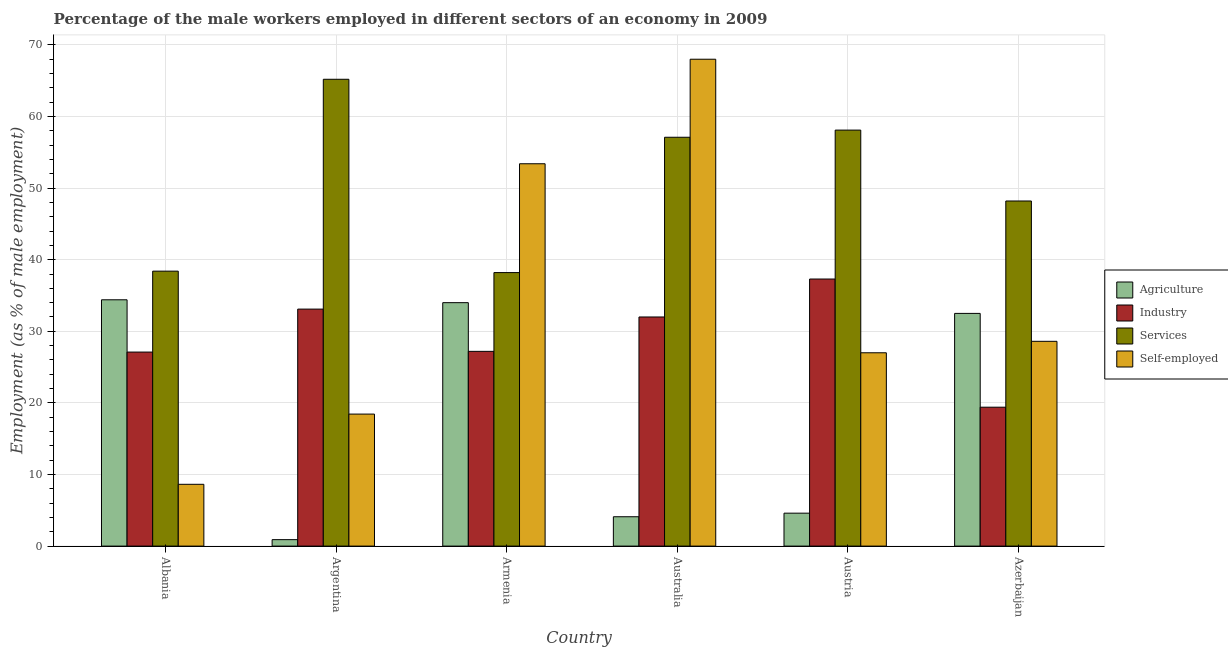How many groups of bars are there?
Make the answer very short. 6. Are the number of bars per tick equal to the number of legend labels?
Your response must be concise. Yes. Are the number of bars on each tick of the X-axis equal?
Keep it short and to the point. Yes. How many bars are there on the 1st tick from the right?
Keep it short and to the point. 4. What is the label of the 2nd group of bars from the left?
Your response must be concise. Argentina. What is the percentage of male workers in agriculture in Austria?
Give a very brief answer. 4.6. Across all countries, what is the maximum percentage of male workers in agriculture?
Your response must be concise. 34.4. Across all countries, what is the minimum percentage of male workers in industry?
Provide a short and direct response. 19.4. In which country was the percentage of male workers in services maximum?
Offer a very short reply. Argentina. In which country was the percentage of male workers in agriculture minimum?
Give a very brief answer. Argentina. What is the total percentage of male workers in services in the graph?
Your answer should be very brief. 305.2. What is the difference between the percentage of self employed male workers in Albania and that in Azerbaijan?
Your response must be concise. -19.97. What is the difference between the percentage of male workers in agriculture in Australia and the percentage of male workers in services in Azerbaijan?
Your answer should be very brief. -44.1. What is the average percentage of male workers in agriculture per country?
Make the answer very short. 18.42. What is the difference between the percentage of self employed male workers and percentage of male workers in industry in Albania?
Your answer should be very brief. -18.47. What is the ratio of the percentage of self employed male workers in Albania to that in Azerbaijan?
Offer a very short reply. 0.3. What is the difference between the highest and the second highest percentage of male workers in agriculture?
Your response must be concise. 0.4. What is the difference between the highest and the lowest percentage of male workers in agriculture?
Your answer should be compact. 33.5. In how many countries, is the percentage of male workers in industry greater than the average percentage of male workers in industry taken over all countries?
Offer a very short reply. 3. Is the sum of the percentage of male workers in services in Armenia and Azerbaijan greater than the maximum percentage of self employed male workers across all countries?
Make the answer very short. Yes. Is it the case that in every country, the sum of the percentage of male workers in services and percentage of male workers in agriculture is greater than the sum of percentage of male workers in industry and percentage of self employed male workers?
Provide a short and direct response. No. What does the 4th bar from the left in Armenia represents?
Your answer should be very brief. Self-employed. What does the 1st bar from the right in Austria represents?
Your response must be concise. Self-employed. Is it the case that in every country, the sum of the percentage of male workers in agriculture and percentage of male workers in industry is greater than the percentage of male workers in services?
Ensure brevity in your answer.  No. How many countries are there in the graph?
Your answer should be compact. 6. What is the difference between two consecutive major ticks on the Y-axis?
Provide a succinct answer. 10. Are the values on the major ticks of Y-axis written in scientific E-notation?
Make the answer very short. No. Where does the legend appear in the graph?
Offer a very short reply. Center right. What is the title of the graph?
Provide a succinct answer. Percentage of the male workers employed in different sectors of an economy in 2009. Does "Greece" appear as one of the legend labels in the graph?
Provide a short and direct response. No. What is the label or title of the X-axis?
Provide a short and direct response. Country. What is the label or title of the Y-axis?
Offer a very short reply. Employment (as % of male employment). What is the Employment (as % of male employment) of Agriculture in Albania?
Offer a very short reply. 34.4. What is the Employment (as % of male employment) of Industry in Albania?
Give a very brief answer. 27.1. What is the Employment (as % of male employment) of Services in Albania?
Give a very brief answer. 38.4. What is the Employment (as % of male employment) in Self-employed in Albania?
Offer a terse response. 8.63. What is the Employment (as % of male employment) of Agriculture in Argentina?
Provide a succinct answer. 0.9. What is the Employment (as % of male employment) of Industry in Argentina?
Provide a succinct answer. 33.1. What is the Employment (as % of male employment) of Services in Argentina?
Provide a short and direct response. 65.2. What is the Employment (as % of male employment) of Self-employed in Argentina?
Provide a short and direct response. 18.44. What is the Employment (as % of male employment) of Industry in Armenia?
Offer a very short reply. 27.2. What is the Employment (as % of male employment) in Services in Armenia?
Your response must be concise. 38.2. What is the Employment (as % of male employment) of Self-employed in Armenia?
Your answer should be compact. 53.4. What is the Employment (as % of male employment) of Agriculture in Australia?
Offer a terse response. 4.1. What is the Employment (as % of male employment) of Services in Australia?
Ensure brevity in your answer.  57.1. What is the Employment (as % of male employment) in Agriculture in Austria?
Ensure brevity in your answer.  4.6. What is the Employment (as % of male employment) in Industry in Austria?
Provide a succinct answer. 37.3. What is the Employment (as % of male employment) in Services in Austria?
Make the answer very short. 58.1. What is the Employment (as % of male employment) of Agriculture in Azerbaijan?
Your answer should be compact. 32.5. What is the Employment (as % of male employment) of Industry in Azerbaijan?
Give a very brief answer. 19.4. What is the Employment (as % of male employment) in Services in Azerbaijan?
Provide a succinct answer. 48.2. What is the Employment (as % of male employment) of Self-employed in Azerbaijan?
Give a very brief answer. 28.6. Across all countries, what is the maximum Employment (as % of male employment) of Agriculture?
Your answer should be very brief. 34.4. Across all countries, what is the maximum Employment (as % of male employment) of Industry?
Keep it short and to the point. 37.3. Across all countries, what is the maximum Employment (as % of male employment) in Services?
Ensure brevity in your answer.  65.2. Across all countries, what is the maximum Employment (as % of male employment) of Self-employed?
Give a very brief answer. 68. Across all countries, what is the minimum Employment (as % of male employment) in Agriculture?
Provide a short and direct response. 0.9. Across all countries, what is the minimum Employment (as % of male employment) of Industry?
Give a very brief answer. 19.4. Across all countries, what is the minimum Employment (as % of male employment) of Services?
Offer a terse response. 38.2. Across all countries, what is the minimum Employment (as % of male employment) in Self-employed?
Keep it short and to the point. 8.63. What is the total Employment (as % of male employment) of Agriculture in the graph?
Your answer should be very brief. 110.5. What is the total Employment (as % of male employment) of Industry in the graph?
Your answer should be compact. 176.1. What is the total Employment (as % of male employment) of Services in the graph?
Offer a very short reply. 305.2. What is the total Employment (as % of male employment) of Self-employed in the graph?
Keep it short and to the point. 204.07. What is the difference between the Employment (as % of male employment) of Agriculture in Albania and that in Argentina?
Your response must be concise. 33.5. What is the difference between the Employment (as % of male employment) in Services in Albania and that in Argentina?
Give a very brief answer. -26.8. What is the difference between the Employment (as % of male employment) in Self-employed in Albania and that in Argentina?
Your response must be concise. -9.81. What is the difference between the Employment (as % of male employment) of Agriculture in Albania and that in Armenia?
Make the answer very short. 0.4. What is the difference between the Employment (as % of male employment) of Industry in Albania and that in Armenia?
Offer a very short reply. -0.1. What is the difference between the Employment (as % of male employment) in Services in Albania and that in Armenia?
Your answer should be compact. 0.2. What is the difference between the Employment (as % of male employment) of Self-employed in Albania and that in Armenia?
Make the answer very short. -44.77. What is the difference between the Employment (as % of male employment) in Agriculture in Albania and that in Australia?
Offer a terse response. 30.3. What is the difference between the Employment (as % of male employment) in Services in Albania and that in Australia?
Keep it short and to the point. -18.7. What is the difference between the Employment (as % of male employment) in Self-employed in Albania and that in Australia?
Provide a succinct answer. -59.37. What is the difference between the Employment (as % of male employment) in Agriculture in Albania and that in Austria?
Offer a terse response. 29.8. What is the difference between the Employment (as % of male employment) in Industry in Albania and that in Austria?
Your response must be concise. -10.2. What is the difference between the Employment (as % of male employment) in Services in Albania and that in Austria?
Offer a terse response. -19.7. What is the difference between the Employment (as % of male employment) in Self-employed in Albania and that in Austria?
Offer a very short reply. -18.37. What is the difference between the Employment (as % of male employment) of Agriculture in Albania and that in Azerbaijan?
Your answer should be very brief. 1.9. What is the difference between the Employment (as % of male employment) of Industry in Albania and that in Azerbaijan?
Give a very brief answer. 7.7. What is the difference between the Employment (as % of male employment) of Services in Albania and that in Azerbaijan?
Keep it short and to the point. -9.8. What is the difference between the Employment (as % of male employment) in Self-employed in Albania and that in Azerbaijan?
Your response must be concise. -19.97. What is the difference between the Employment (as % of male employment) in Agriculture in Argentina and that in Armenia?
Your response must be concise. -33.1. What is the difference between the Employment (as % of male employment) in Industry in Argentina and that in Armenia?
Provide a short and direct response. 5.9. What is the difference between the Employment (as % of male employment) in Self-employed in Argentina and that in Armenia?
Your answer should be compact. -34.96. What is the difference between the Employment (as % of male employment) of Agriculture in Argentina and that in Australia?
Your response must be concise. -3.2. What is the difference between the Employment (as % of male employment) in Industry in Argentina and that in Australia?
Provide a succinct answer. 1.1. What is the difference between the Employment (as % of male employment) of Self-employed in Argentina and that in Australia?
Offer a terse response. -49.56. What is the difference between the Employment (as % of male employment) of Industry in Argentina and that in Austria?
Your answer should be very brief. -4.2. What is the difference between the Employment (as % of male employment) in Self-employed in Argentina and that in Austria?
Offer a very short reply. -8.56. What is the difference between the Employment (as % of male employment) in Agriculture in Argentina and that in Azerbaijan?
Give a very brief answer. -31.6. What is the difference between the Employment (as % of male employment) of Services in Argentina and that in Azerbaijan?
Your answer should be compact. 17. What is the difference between the Employment (as % of male employment) in Self-employed in Argentina and that in Azerbaijan?
Your answer should be very brief. -10.16. What is the difference between the Employment (as % of male employment) of Agriculture in Armenia and that in Australia?
Provide a short and direct response. 29.9. What is the difference between the Employment (as % of male employment) of Industry in Armenia and that in Australia?
Keep it short and to the point. -4.8. What is the difference between the Employment (as % of male employment) in Services in Armenia and that in Australia?
Keep it short and to the point. -18.9. What is the difference between the Employment (as % of male employment) in Self-employed in Armenia and that in Australia?
Keep it short and to the point. -14.6. What is the difference between the Employment (as % of male employment) of Agriculture in Armenia and that in Austria?
Provide a short and direct response. 29.4. What is the difference between the Employment (as % of male employment) of Services in Armenia and that in Austria?
Offer a terse response. -19.9. What is the difference between the Employment (as % of male employment) in Self-employed in Armenia and that in Austria?
Provide a succinct answer. 26.4. What is the difference between the Employment (as % of male employment) in Agriculture in Armenia and that in Azerbaijan?
Keep it short and to the point. 1.5. What is the difference between the Employment (as % of male employment) in Self-employed in Armenia and that in Azerbaijan?
Your answer should be compact. 24.8. What is the difference between the Employment (as % of male employment) of Agriculture in Australia and that in Austria?
Ensure brevity in your answer.  -0.5. What is the difference between the Employment (as % of male employment) of Self-employed in Australia and that in Austria?
Make the answer very short. 41. What is the difference between the Employment (as % of male employment) of Agriculture in Australia and that in Azerbaijan?
Ensure brevity in your answer.  -28.4. What is the difference between the Employment (as % of male employment) in Services in Australia and that in Azerbaijan?
Offer a terse response. 8.9. What is the difference between the Employment (as % of male employment) of Self-employed in Australia and that in Azerbaijan?
Provide a succinct answer. 39.4. What is the difference between the Employment (as % of male employment) in Agriculture in Austria and that in Azerbaijan?
Provide a succinct answer. -27.9. What is the difference between the Employment (as % of male employment) in Self-employed in Austria and that in Azerbaijan?
Offer a terse response. -1.6. What is the difference between the Employment (as % of male employment) of Agriculture in Albania and the Employment (as % of male employment) of Industry in Argentina?
Your answer should be compact. 1.3. What is the difference between the Employment (as % of male employment) of Agriculture in Albania and the Employment (as % of male employment) of Services in Argentina?
Give a very brief answer. -30.8. What is the difference between the Employment (as % of male employment) of Agriculture in Albania and the Employment (as % of male employment) of Self-employed in Argentina?
Give a very brief answer. 15.96. What is the difference between the Employment (as % of male employment) of Industry in Albania and the Employment (as % of male employment) of Services in Argentina?
Ensure brevity in your answer.  -38.1. What is the difference between the Employment (as % of male employment) in Industry in Albania and the Employment (as % of male employment) in Self-employed in Argentina?
Make the answer very short. 8.66. What is the difference between the Employment (as % of male employment) of Services in Albania and the Employment (as % of male employment) of Self-employed in Argentina?
Your response must be concise. 19.96. What is the difference between the Employment (as % of male employment) of Agriculture in Albania and the Employment (as % of male employment) of Self-employed in Armenia?
Keep it short and to the point. -19. What is the difference between the Employment (as % of male employment) of Industry in Albania and the Employment (as % of male employment) of Self-employed in Armenia?
Ensure brevity in your answer.  -26.3. What is the difference between the Employment (as % of male employment) of Agriculture in Albania and the Employment (as % of male employment) of Industry in Australia?
Provide a short and direct response. 2.4. What is the difference between the Employment (as % of male employment) in Agriculture in Albania and the Employment (as % of male employment) in Services in Australia?
Keep it short and to the point. -22.7. What is the difference between the Employment (as % of male employment) in Agriculture in Albania and the Employment (as % of male employment) in Self-employed in Australia?
Give a very brief answer. -33.6. What is the difference between the Employment (as % of male employment) of Industry in Albania and the Employment (as % of male employment) of Self-employed in Australia?
Offer a very short reply. -40.9. What is the difference between the Employment (as % of male employment) of Services in Albania and the Employment (as % of male employment) of Self-employed in Australia?
Offer a terse response. -29.6. What is the difference between the Employment (as % of male employment) in Agriculture in Albania and the Employment (as % of male employment) in Industry in Austria?
Your response must be concise. -2.9. What is the difference between the Employment (as % of male employment) in Agriculture in Albania and the Employment (as % of male employment) in Services in Austria?
Your answer should be very brief. -23.7. What is the difference between the Employment (as % of male employment) of Agriculture in Albania and the Employment (as % of male employment) of Self-employed in Austria?
Ensure brevity in your answer.  7.4. What is the difference between the Employment (as % of male employment) of Industry in Albania and the Employment (as % of male employment) of Services in Austria?
Offer a terse response. -31. What is the difference between the Employment (as % of male employment) in Services in Albania and the Employment (as % of male employment) in Self-employed in Austria?
Make the answer very short. 11.4. What is the difference between the Employment (as % of male employment) of Agriculture in Albania and the Employment (as % of male employment) of Services in Azerbaijan?
Provide a succinct answer. -13.8. What is the difference between the Employment (as % of male employment) in Agriculture in Albania and the Employment (as % of male employment) in Self-employed in Azerbaijan?
Make the answer very short. 5.8. What is the difference between the Employment (as % of male employment) of Industry in Albania and the Employment (as % of male employment) of Services in Azerbaijan?
Ensure brevity in your answer.  -21.1. What is the difference between the Employment (as % of male employment) of Industry in Albania and the Employment (as % of male employment) of Self-employed in Azerbaijan?
Ensure brevity in your answer.  -1.5. What is the difference between the Employment (as % of male employment) in Agriculture in Argentina and the Employment (as % of male employment) in Industry in Armenia?
Your answer should be compact. -26.3. What is the difference between the Employment (as % of male employment) of Agriculture in Argentina and the Employment (as % of male employment) of Services in Armenia?
Offer a terse response. -37.3. What is the difference between the Employment (as % of male employment) of Agriculture in Argentina and the Employment (as % of male employment) of Self-employed in Armenia?
Your answer should be very brief. -52.5. What is the difference between the Employment (as % of male employment) of Industry in Argentina and the Employment (as % of male employment) of Services in Armenia?
Make the answer very short. -5.1. What is the difference between the Employment (as % of male employment) in Industry in Argentina and the Employment (as % of male employment) in Self-employed in Armenia?
Provide a short and direct response. -20.3. What is the difference between the Employment (as % of male employment) in Services in Argentina and the Employment (as % of male employment) in Self-employed in Armenia?
Your answer should be compact. 11.8. What is the difference between the Employment (as % of male employment) in Agriculture in Argentina and the Employment (as % of male employment) in Industry in Australia?
Ensure brevity in your answer.  -31.1. What is the difference between the Employment (as % of male employment) of Agriculture in Argentina and the Employment (as % of male employment) of Services in Australia?
Make the answer very short. -56.2. What is the difference between the Employment (as % of male employment) of Agriculture in Argentina and the Employment (as % of male employment) of Self-employed in Australia?
Keep it short and to the point. -67.1. What is the difference between the Employment (as % of male employment) in Industry in Argentina and the Employment (as % of male employment) in Self-employed in Australia?
Your answer should be compact. -34.9. What is the difference between the Employment (as % of male employment) of Agriculture in Argentina and the Employment (as % of male employment) of Industry in Austria?
Provide a short and direct response. -36.4. What is the difference between the Employment (as % of male employment) in Agriculture in Argentina and the Employment (as % of male employment) in Services in Austria?
Your answer should be very brief. -57.2. What is the difference between the Employment (as % of male employment) in Agriculture in Argentina and the Employment (as % of male employment) in Self-employed in Austria?
Make the answer very short. -26.1. What is the difference between the Employment (as % of male employment) in Services in Argentina and the Employment (as % of male employment) in Self-employed in Austria?
Give a very brief answer. 38.2. What is the difference between the Employment (as % of male employment) in Agriculture in Argentina and the Employment (as % of male employment) in Industry in Azerbaijan?
Keep it short and to the point. -18.5. What is the difference between the Employment (as % of male employment) in Agriculture in Argentina and the Employment (as % of male employment) in Services in Azerbaijan?
Offer a terse response. -47.3. What is the difference between the Employment (as % of male employment) in Agriculture in Argentina and the Employment (as % of male employment) in Self-employed in Azerbaijan?
Offer a very short reply. -27.7. What is the difference between the Employment (as % of male employment) of Industry in Argentina and the Employment (as % of male employment) of Services in Azerbaijan?
Ensure brevity in your answer.  -15.1. What is the difference between the Employment (as % of male employment) of Services in Argentina and the Employment (as % of male employment) of Self-employed in Azerbaijan?
Provide a succinct answer. 36.6. What is the difference between the Employment (as % of male employment) of Agriculture in Armenia and the Employment (as % of male employment) of Services in Australia?
Make the answer very short. -23.1. What is the difference between the Employment (as % of male employment) of Agriculture in Armenia and the Employment (as % of male employment) of Self-employed in Australia?
Your answer should be compact. -34. What is the difference between the Employment (as % of male employment) of Industry in Armenia and the Employment (as % of male employment) of Services in Australia?
Give a very brief answer. -29.9. What is the difference between the Employment (as % of male employment) in Industry in Armenia and the Employment (as % of male employment) in Self-employed in Australia?
Provide a short and direct response. -40.8. What is the difference between the Employment (as % of male employment) in Services in Armenia and the Employment (as % of male employment) in Self-employed in Australia?
Your answer should be very brief. -29.8. What is the difference between the Employment (as % of male employment) of Agriculture in Armenia and the Employment (as % of male employment) of Services in Austria?
Provide a short and direct response. -24.1. What is the difference between the Employment (as % of male employment) in Agriculture in Armenia and the Employment (as % of male employment) in Self-employed in Austria?
Provide a short and direct response. 7. What is the difference between the Employment (as % of male employment) of Industry in Armenia and the Employment (as % of male employment) of Services in Austria?
Your answer should be compact. -30.9. What is the difference between the Employment (as % of male employment) in Industry in Armenia and the Employment (as % of male employment) in Self-employed in Austria?
Your response must be concise. 0.2. What is the difference between the Employment (as % of male employment) of Agriculture in Armenia and the Employment (as % of male employment) of Industry in Azerbaijan?
Keep it short and to the point. 14.6. What is the difference between the Employment (as % of male employment) in Agriculture in Armenia and the Employment (as % of male employment) in Self-employed in Azerbaijan?
Your response must be concise. 5.4. What is the difference between the Employment (as % of male employment) of Industry in Armenia and the Employment (as % of male employment) of Self-employed in Azerbaijan?
Your answer should be very brief. -1.4. What is the difference between the Employment (as % of male employment) in Agriculture in Australia and the Employment (as % of male employment) in Industry in Austria?
Offer a very short reply. -33.2. What is the difference between the Employment (as % of male employment) of Agriculture in Australia and the Employment (as % of male employment) of Services in Austria?
Your answer should be compact. -54. What is the difference between the Employment (as % of male employment) of Agriculture in Australia and the Employment (as % of male employment) of Self-employed in Austria?
Offer a terse response. -22.9. What is the difference between the Employment (as % of male employment) in Industry in Australia and the Employment (as % of male employment) in Services in Austria?
Offer a very short reply. -26.1. What is the difference between the Employment (as % of male employment) in Services in Australia and the Employment (as % of male employment) in Self-employed in Austria?
Your answer should be very brief. 30.1. What is the difference between the Employment (as % of male employment) in Agriculture in Australia and the Employment (as % of male employment) in Industry in Azerbaijan?
Offer a very short reply. -15.3. What is the difference between the Employment (as % of male employment) in Agriculture in Australia and the Employment (as % of male employment) in Services in Azerbaijan?
Your answer should be compact. -44.1. What is the difference between the Employment (as % of male employment) of Agriculture in Australia and the Employment (as % of male employment) of Self-employed in Azerbaijan?
Make the answer very short. -24.5. What is the difference between the Employment (as % of male employment) of Industry in Australia and the Employment (as % of male employment) of Services in Azerbaijan?
Give a very brief answer. -16.2. What is the difference between the Employment (as % of male employment) in Agriculture in Austria and the Employment (as % of male employment) in Industry in Azerbaijan?
Give a very brief answer. -14.8. What is the difference between the Employment (as % of male employment) in Agriculture in Austria and the Employment (as % of male employment) in Services in Azerbaijan?
Ensure brevity in your answer.  -43.6. What is the difference between the Employment (as % of male employment) of Agriculture in Austria and the Employment (as % of male employment) of Self-employed in Azerbaijan?
Provide a succinct answer. -24. What is the difference between the Employment (as % of male employment) of Industry in Austria and the Employment (as % of male employment) of Services in Azerbaijan?
Your answer should be very brief. -10.9. What is the difference between the Employment (as % of male employment) of Services in Austria and the Employment (as % of male employment) of Self-employed in Azerbaijan?
Offer a terse response. 29.5. What is the average Employment (as % of male employment) in Agriculture per country?
Make the answer very short. 18.42. What is the average Employment (as % of male employment) in Industry per country?
Ensure brevity in your answer.  29.35. What is the average Employment (as % of male employment) in Services per country?
Provide a short and direct response. 50.87. What is the average Employment (as % of male employment) of Self-employed per country?
Give a very brief answer. 34.01. What is the difference between the Employment (as % of male employment) of Agriculture and Employment (as % of male employment) of Services in Albania?
Make the answer very short. -4. What is the difference between the Employment (as % of male employment) in Agriculture and Employment (as % of male employment) in Self-employed in Albania?
Offer a terse response. 25.77. What is the difference between the Employment (as % of male employment) in Industry and Employment (as % of male employment) in Services in Albania?
Your answer should be very brief. -11.3. What is the difference between the Employment (as % of male employment) of Industry and Employment (as % of male employment) of Self-employed in Albania?
Offer a very short reply. 18.47. What is the difference between the Employment (as % of male employment) in Services and Employment (as % of male employment) in Self-employed in Albania?
Your response must be concise. 29.77. What is the difference between the Employment (as % of male employment) of Agriculture and Employment (as % of male employment) of Industry in Argentina?
Give a very brief answer. -32.2. What is the difference between the Employment (as % of male employment) of Agriculture and Employment (as % of male employment) of Services in Argentina?
Make the answer very short. -64.3. What is the difference between the Employment (as % of male employment) of Agriculture and Employment (as % of male employment) of Self-employed in Argentina?
Your answer should be compact. -17.54. What is the difference between the Employment (as % of male employment) of Industry and Employment (as % of male employment) of Services in Argentina?
Provide a short and direct response. -32.1. What is the difference between the Employment (as % of male employment) in Industry and Employment (as % of male employment) in Self-employed in Argentina?
Provide a succinct answer. 14.66. What is the difference between the Employment (as % of male employment) in Services and Employment (as % of male employment) in Self-employed in Argentina?
Give a very brief answer. 46.76. What is the difference between the Employment (as % of male employment) in Agriculture and Employment (as % of male employment) in Self-employed in Armenia?
Provide a succinct answer. -19.4. What is the difference between the Employment (as % of male employment) in Industry and Employment (as % of male employment) in Self-employed in Armenia?
Ensure brevity in your answer.  -26.2. What is the difference between the Employment (as % of male employment) in Services and Employment (as % of male employment) in Self-employed in Armenia?
Provide a succinct answer. -15.2. What is the difference between the Employment (as % of male employment) of Agriculture and Employment (as % of male employment) of Industry in Australia?
Keep it short and to the point. -27.9. What is the difference between the Employment (as % of male employment) in Agriculture and Employment (as % of male employment) in Services in Australia?
Give a very brief answer. -53. What is the difference between the Employment (as % of male employment) in Agriculture and Employment (as % of male employment) in Self-employed in Australia?
Make the answer very short. -63.9. What is the difference between the Employment (as % of male employment) of Industry and Employment (as % of male employment) of Services in Australia?
Provide a short and direct response. -25.1. What is the difference between the Employment (as % of male employment) in Industry and Employment (as % of male employment) in Self-employed in Australia?
Offer a terse response. -36. What is the difference between the Employment (as % of male employment) in Agriculture and Employment (as % of male employment) in Industry in Austria?
Give a very brief answer. -32.7. What is the difference between the Employment (as % of male employment) of Agriculture and Employment (as % of male employment) of Services in Austria?
Your answer should be compact. -53.5. What is the difference between the Employment (as % of male employment) in Agriculture and Employment (as % of male employment) in Self-employed in Austria?
Offer a very short reply. -22.4. What is the difference between the Employment (as % of male employment) of Industry and Employment (as % of male employment) of Services in Austria?
Ensure brevity in your answer.  -20.8. What is the difference between the Employment (as % of male employment) in Industry and Employment (as % of male employment) in Self-employed in Austria?
Your answer should be very brief. 10.3. What is the difference between the Employment (as % of male employment) of Services and Employment (as % of male employment) of Self-employed in Austria?
Your response must be concise. 31.1. What is the difference between the Employment (as % of male employment) of Agriculture and Employment (as % of male employment) of Services in Azerbaijan?
Your response must be concise. -15.7. What is the difference between the Employment (as % of male employment) of Industry and Employment (as % of male employment) of Services in Azerbaijan?
Ensure brevity in your answer.  -28.8. What is the difference between the Employment (as % of male employment) of Services and Employment (as % of male employment) of Self-employed in Azerbaijan?
Make the answer very short. 19.6. What is the ratio of the Employment (as % of male employment) in Agriculture in Albania to that in Argentina?
Your response must be concise. 38.22. What is the ratio of the Employment (as % of male employment) in Industry in Albania to that in Argentina?
Offer a very short reply. 0.82. What is the ratio of the Employment (as % of male employment) in Services in Albania to that in Argentina?
Your answer should be very brief. 0.59. What is the ratio of the Employment (as % of male employment) of Self-employed in Albania to that in Argentina?
Your answer should be compact. 0.47. What is the ratio of the Employment (as % of male employment) in Agriculture in Albania to that in Armenia?
Give a very brief answer. 1.01. What is the ratio of the Employment (as % of male employment) in Industry in Albania to that in Armenia?
Your answer should be compact. 1. What is the ratio of the Employment (as % of male employment) of Self-employed in Albania to that in Armenia?
Keep it short and to the point. 0.16. What is the ratio of the Employment (as % of male employment) in Agriculture in Albania to that in Australia?
Your answer should be compact. 8.39. What is the ratio of the Employment (as % of male employment) in Industry in Albania to that in Australia?
Your answer should be very brief. 0.85. What is the ratio of the Employment (as % of male employment) of Services in Albania to that in Australia?
Your answer should be compact. 0.67. What is the ratio of the Employment (as % of male employment) of Self-employed in Albania to that in Australia?
Offer a terse response. 0.13. What is the ratio of the Employment (as % of male employment) in Agriculture in Albania to that in Austria?
Make the answer very short. 7.48. What is the ratio of the Employment (as % of male employment) of Industry in Albania to that in Austria?
Keep it short and to the point. 0.73. What is the ratio of the Employment (as % of male employment) of Services in Albania to that in Austria?
Your response must be concise. 0.66. What is the ratio of the Employment (as % of male employment) of Self-employed in Albania to that in Austria?
Provide a short and direct response. 0.32. What is the ratio of the Employment (as % of male employment) of Agriculture in Albania to that in Azerbaijan?
Provide a short and direct response. 1.06. What is the ratio of the Employment (as % of male employment) in Industry in Albania to that in Azerbaijan?
Ensure brevity in your answer.  1.4. What is the ratio of the Employment (as % of male employment) of Services in Albania to that in Azerbaijan?
Your answer should be very brief. 0.8. What is the ratio of the Employment (as % of male employment) in Self-employed in Albania to that in Azerbaijan?
Keep it short and to the point. 0.3. What is the ratio of the Employment (as % of male employment) of Agriculture in Argentina to that in Armenia?
Keep it short and to the point. 0.03. What is the ratio of the Employment (as % of male employment) of Industry in Argentina to that in Armenia?
Offer a terse response. 1.22. What is the ratio of the Employment (as % of male employment) in Services in Argentina to that in Armenia?
Make the answer very short. 1.71. What is the ratio of the Employment (as % of male employment) of Self-employed in Argentina to that in Armenia?
Give a very brief answer. 0.35. What is the ratio of the Employment (as % of male employment) of Agriculture in Argentina to that in Australia?
Ensure brevity in your answer.  0.22. What is the ratio of the Employment (as % of male employment) of Industry in Argentina to that in Australia?
Your answer should be very brief. 1.03. What is the ratio of the Employment (as % of male employment) of Services in Argentina to that in Australia?
Your answer should be compact. 1.14. What is the ratio of the Employment (as % of male employment) of Self-employed in Argentina to that in Australia?
Make the answer very short. 0.27. What is the ratio of the Employment (as % of male employment) in Agriculture in Argentina to that in Austria?
Your response must be concise. 0.2. What is the ratio of the Employment (as % of male employment) of Industry in Argentina to that in Austria?
Keep it short and to the point. 0.89. What is the ratio of the Employment (as % of male employment) of Services in Argentina to that in Austria?
Ensure brevity in your answer.  1.12. What is the ratio of the Employment (as % of male employment) of Self-employed in Argentina to that in Austria?
Keep it short and to the point. 0.68. What is the ratio of the Employment (as % of male employment) of Agriculture in Argentina to that in Azerbaijan?
Offer a terse response. 0.03. What is the ratio of the Employment (as % of male employment) of Industry in Argentina to that in Azerbaijan?
Your answer should be compact. 1.71. What is the ratio of the Employment (as % of male employment) of Services in Argentina to that in Azerbaijan?
Keep it short and to the point. 1.35. What is the ratio of the Employment (as % of male employment) in Self-employed in Argentina to that in Azerbaijan?
Ensure brevity in your answer.  0.64. What is the ratio of the Employment (as % of male employment) in Agriculture in Armenia to that in Australia?
Make the answer very short. 8.29. What is the ratio of the Employment (as % of male employment) of Industry in Armenia to that in Australia?
Ensure brevity in your answer.  0.85. What is the ratio of the Employment (as % of male employment) in Services in Armenia to that in Australia?
Provide a succinct answer. 0.67. What is the ratio of the Employment (as % of male employment) of Self-employed in Armenia to that in Australia?
Your response must be concise. 0.79. What is the ratio of the Employment (as % of male employment) in Agriculture in Armenia to that in Austria?
Keep it short and to the point. 7.39. What is the ratio of the Employment (as % of male employment) of Industry in Armenia to that in Austria?
Your answer should be very brief. 0.73. What is the ratio of the Employment (as % of male employment) in Services in Armenia to that in Austria?
Give a very brief answer. 0.66. What is the ratio of the Employment (as % of male employment) of Self-employed in Armenia to that in Austria?
Make the answer very short. 1.98. What is the ratio of the Employment (as % of male employment) in Agriculture in Armenia to that in Azerbaijan?
Give a very brief answer. 1.05. What is the ratio of the Employment (as % of male employment) in Industry in Armenia to that in Azerbaijan?
Keep it short and to the point. 1.4. What is the ratio of the Employment (as % of male employment) in Services in Armenia to that in Azerbaijan?
Offer a terse response. 0.79. What is the ratio of the Employment (as % of male employment) of Self-employed in Armenia to that in Azerbaijan?
Keep it short and to the point. 1.87. What is the ratio of the Employment (as % of male employment) of Agriculture in Australia to that in Austria?
Offer a terse response. 0.89. What is the ratio of the Employment (as % of male employment) in Industry in Australia to that in Austria?
Ensure brevity in your answer.  0.86. What is the ratio of the Employment (as % of male employment) in Services in Australia to that in Austria?
Your answer should be compact. 0.98. What is the ratio of the Employment (as % of male employment) of Self-employed in Australia to that in Austria?
Your response must be concise. 2.52. What is the ratio of the Employment (as % of male employment) in Agriculture in Australia to that in Azerbaijan?
Your answer should be compact. 0.13. What is the ratio of the Employment (as % of male employment) in Industry in Australia to that in Azerbaijan?
Keep it short and to the point. 1.65. What is the ratio of the Employment (as % of male employment) in Services in Australia to that in Azerbaijan?
Offer a terse response. 1.18. What is the ratio of the Employment (as % of male employment) in Self-employed in Australia to that in Azerbaijan?
Offer a very short reply. 2.38. What is the ratio of the Employment (as % of male employment) in Agriculture in Austria to that in Azerbaijan?
Your answer should be compact. 0.14. What is the ratio of the Employment (as % of male employment) of Industry in Austria to that in Azerbaijan?
Provide a succinct answer. 1.92. What is the ratio of the Employment (as % of male employment) in Services in Austria to that in Azerbaijan?
Your answer should be very brief. 1.21. What is the ratio of the Employment (as % of male employment) in Self-employed in Austria to that in Azerbaijan?
Offer a terse response. 0.94. What is the difference between the highest and the second highest Employment (as % of male employment) in Self-employed?
Provide a short and direct response. 14.6. What is the difference between the highest and the lowest Employment (as % of male employment) of Agriculture?
Provide a short and direct response. 33.5. What is the difference between the highest and the lowest Employment (as % of male employment) of Services?
Offer a very short reply. 27. What is the difference between the highest and the lowest Employment (as % of male employment) in Self-employed?
Offer a very short reply. 59.37. 